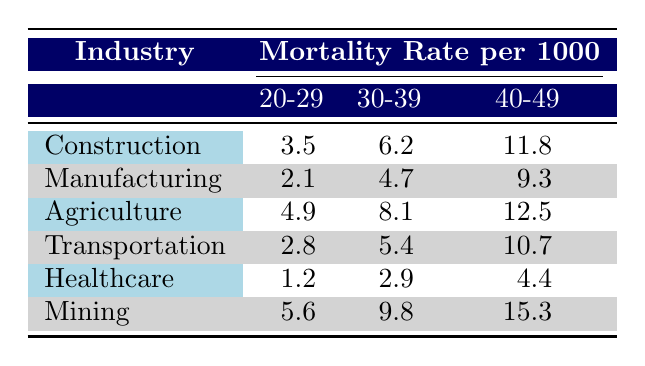What is the mortality rate for employees in the Construction industry aged 30-39? The table lists the mortality rate per 1000 for the Construction industry. For the age group 30-39, the table specifies a value of 6.2.
Answer: 6.2 What is the highest mortality rate for the age group 40-49 across all industries? By reviewing the table, we see that the highest mortality rate for the age group 40-49 is in the Mining industry at 15.3.
Answer: 15.3 Which industry has the lowest mortality rate for the age group 20-29? Looking at the table, Healthcare shows a mortality rate of 1.2 for the age group 20-29, which is lower than the rates in Construction (3.5), Manufacturing (2.1), Agriculture (4.9), Transportation (2.8), and Mining (5.6).
Answer: Healthcare What is the average mortality rate for the age group 30-39 across all industries? To find the average, sum the mortality rates for this age group from each industry: 6.2 (Construction) + 4.7 (Manufacturing) + 8.1 (Agriculture) + 5.4 (Transportation) + 2.9 (Healthcare) + 9.8 (Mining) = 37.1. Then, divide by the number of industries (6): 37.1 / 6 = approximately 6.2.
Answer: 6.2 Is the mortality rate for the Agriculture industry higher at age 30-39 than for Healthcare at the same age? The table shows that the mortality rate for Agriculture at age 30-39 is 8.1, while for Healthcare it is 2.9. Since 8.1 is greater than 2.9, we can conclude that this statement is true.
Answer: Yes What is the difference in mortality rates between the Manufacturing and Transportation industries for the age group 40-49? From the table, Manufacturing has a mortality rate of 9.3 and Transportation has a rate of 10.7 for the age group 40-49. The difference is 10.7 - 9.3 = 1.4.
Answer: 1.4 For the age group 20-29, which industry has a higher mortality rate, Construction or Mining? The table lists the mortality rate for Construction at 3.5 and for Mining at 5.6 in the 20-29 age group. Since 5.6 is greater than 3.5, Mining has the higher rate.
Answer: Mining What is the total mortality rate for all age groups in the Healthcare industry? The mortality rates for Healthcare are 1.2 (20-29), 2.9 (30-39), and 4.4 (40-49). Summing these gives 1.2 + 2.9 + 4.4 = 8.5.
Answer: 8.5 